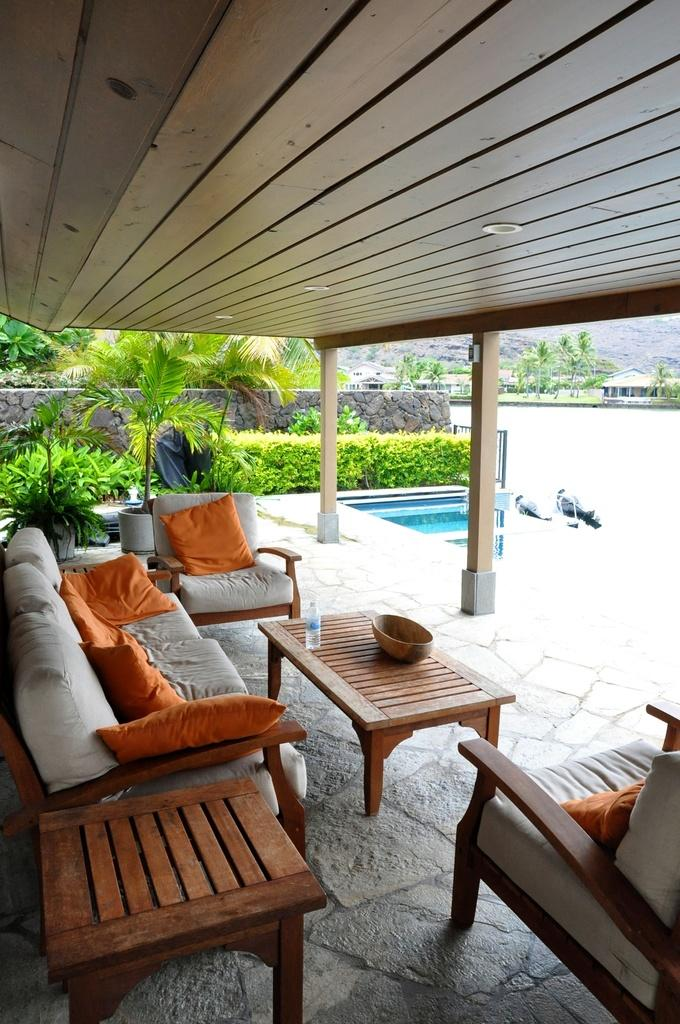What type of furniture is present in the image? There is a sofa and two chairs in the image. What other piece of furniture can be seen in the image? There is a table in the image. What can be seen outside the room in the image? Trees and plants are visible in the image. What type of agreement was reached by the society in the image? There is no reference to a society or any agreement in the image. 